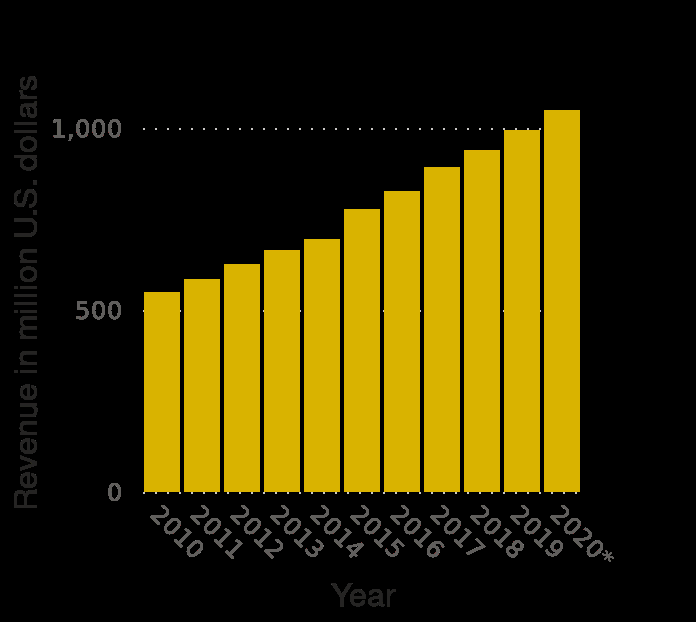<image>
What does the y-axis of the bar plot represent? The y-axis of the bar plot represents revenue in million U.S. dollars. What is the highest value that can be plotted on the y-axis? The highest value that can be plotted on the y-axis is 1,000 million U.S. dollars. What is the lowest value that can be plotted on the y-axis? The lowest value that can be plotted on the y-axis is 0 million U.S. dollars. Describe the following image in detail This is a bar plot labeled Major League Baseball sponsorship revenue from 2010 to 2020 (in million U.S. dollars). The x-axis plots Year using categorical scale from 2010 to  while the y-axis plots Revenue in million U.S. dollars on linear scale from 0 to 1,000. please summary the statistics and relations of the chart From this bar chart I can see that sponsorship revenue in Major League Baseball has doubled in 10 years. Over the 10 years between 2010 and 2020 the revenue was steadily increasing. Offer a thorough analysis of the image. The amount of revenue in US dollars increased over a 10 year period in major league baseball sponsorship. 